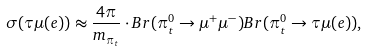Convert formula to latex. <formula><loc_0><loc_0><loc_500><loc_500>\sigma ( \tau \mu ( e ) ) \approx \frac { 4 \pi } { m _ { \pi _ { t } } } \cdot B r ( \pi _ { t } ^ { 0 } \rightarrow \mu ^ { + } \mu ^ { - } ) B r ( \pi _ { t } ^ { 0 } \rightarrow \tau \mu ( e ) ) ,</formula> 